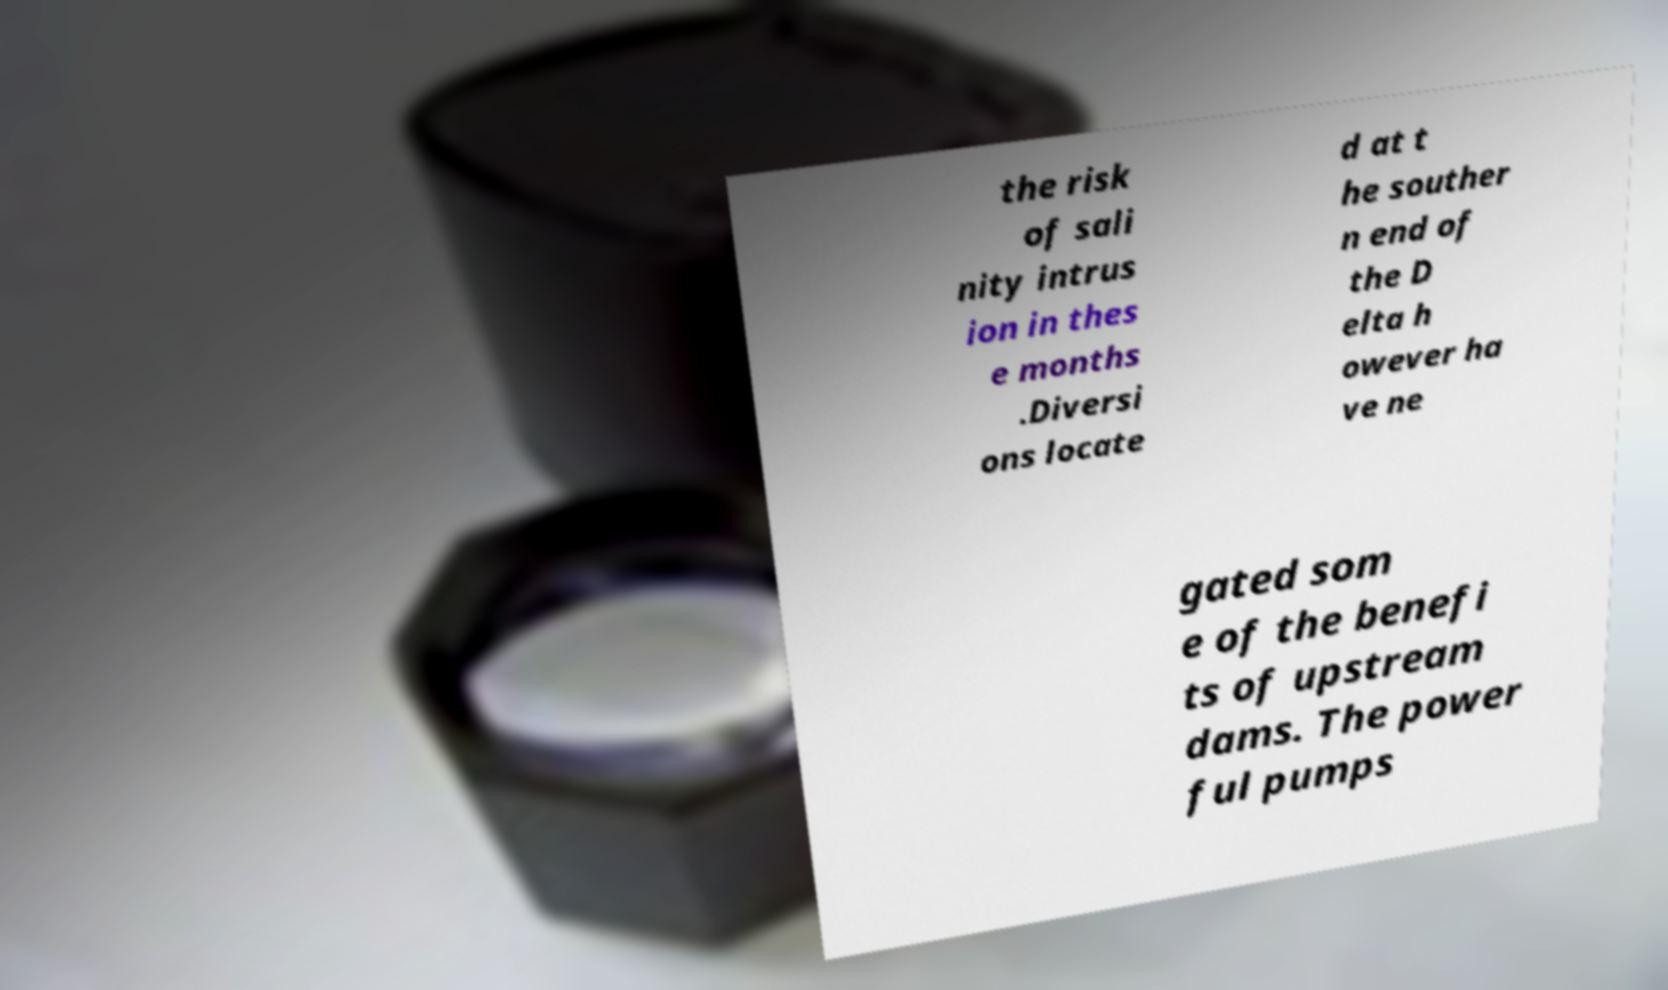For documentation purposes, I need the text within this image transcribed. Could you provide that? the risk of sali nity intrus ion in thes e months .Diversi ons locate d at t he souther n end of the D elta h owever ha ve ne gated som e of the benefi ts of upstream dams. The power ful pumps 